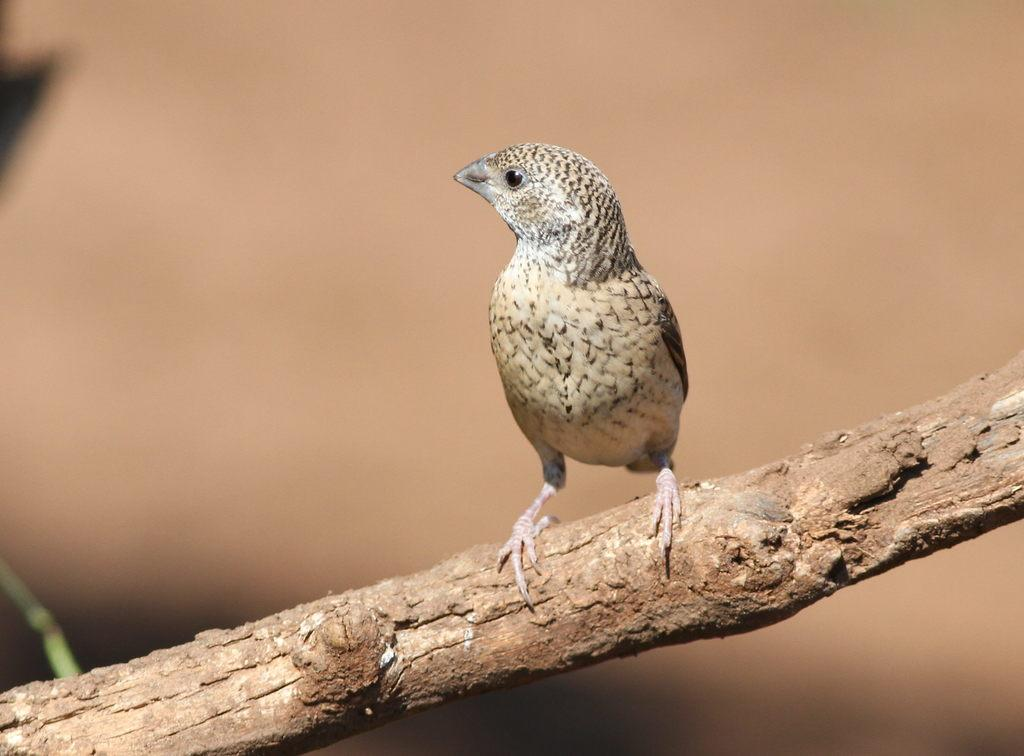What type of bird is in the image? There is a woodpecker finch in the image. What is the woodpecker finch doing in the image? The woodpecker finch is sitting on a stick. What type of sand can be seen in the image? There is no sand present in the image; it features a woodpecker finch sitting on a stick. What request is the woodpecker finch making in the image? The image does not depict the woodpecker finch making any requests. 